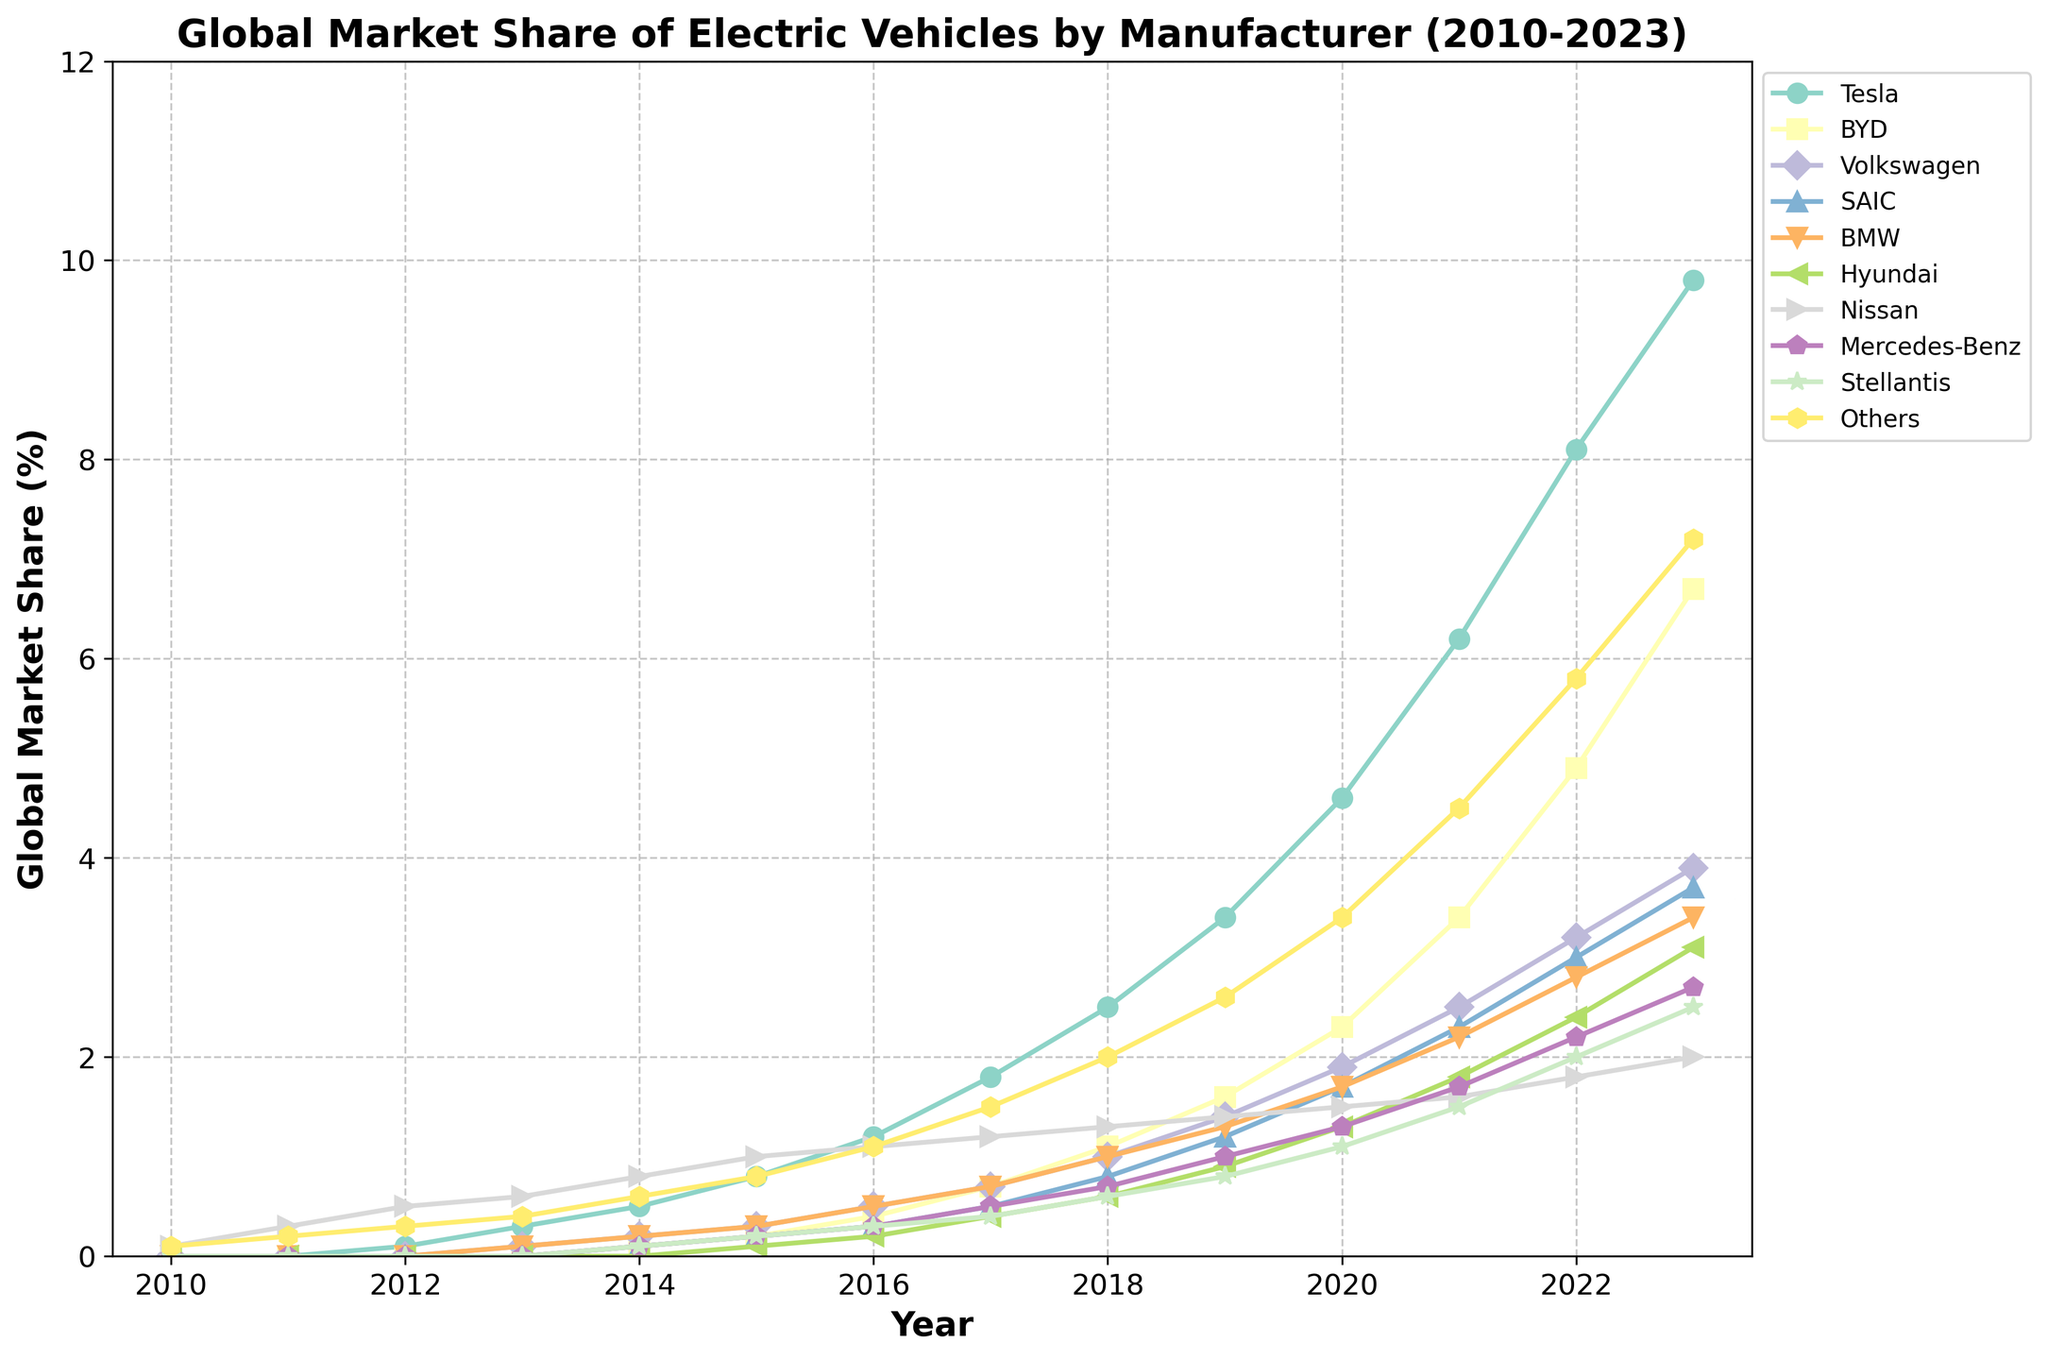what is the global market share of Tesla in 2022? From the line chart, locate the year 2022 on the x-axis and follow it up to where the Tesla line intersects. The value shown is Tesla's market share for that year.
Answer: 8.1% Which manufacturer had the second highest market share in 2023? Look at the data points for the year 2023. Identify the second highest value after Tesla's and check which manufacturer corresponds to that value.
Answer: BYD How did BMW's market share change between 2010 and 2023? Refer to BMW's line on the chart. Note the initial value in 2010 and the final value in 2023. Find the difference to understand the change.
Answer: From 0.0% to 3.4%, an increase of 3.4 percentage points Comparing 2015, which manufacturer had the higher market share between BYD and Volkswagen? Locate the year 2015 on the x-axis, then compare the vertical positions of the lines for BYD and Volkswagen. The higher line represents the manufacturer with a higher market share.
Answer: Volkswagen (0.3% vs. 0.2%) What is the average market share of Nissan from 2010 to 2023? Sum up the market share values for Nissan for all the years from the chart and divide by the number of years (14).
Answer: (0.1+0.3+0.5+...+2.0)/14 = 1.179% Between 2021 and 2022, which manufacturer had the greatest increase in market share? Identify the market share values for both years for each manufacturer. Calculate the difference, and the greatest difference indicates the manufacturer with the greatest increase.
Answer: BYD (4.9% - 3.4% = 1.5 percentage points) Which manufacturer had a steady increase in market share every year from 2010 to 2023? Observe the trend lines for all manufacturers and look for a line that continuously moves upwards without any dips.
Answer: Tesla What is the combined market share of SAIC and Hyundai in 2020? Locate the year 2020 on the x-axis and find the market share values for SAIC and Hyundai. Sum these values.
Answer: 1.7% + 1.3% = 3.0% In 2018, which had a higher market share: companies grouped under 'Others' or Mercedes-Benz? Locate the year 2018 and compare the vertical positions of the line for 'Others' and the line for Mercedes-Benz.
Answer: Others (2.0% vs. 0.7%) Assuming that the trend continues, which company is likely to surpass 10% market share first after 2023? Observe the growth patterns of lines approaching 10% market share. Tesla appears to have a steeper growth trend.
Answer: Tesla 